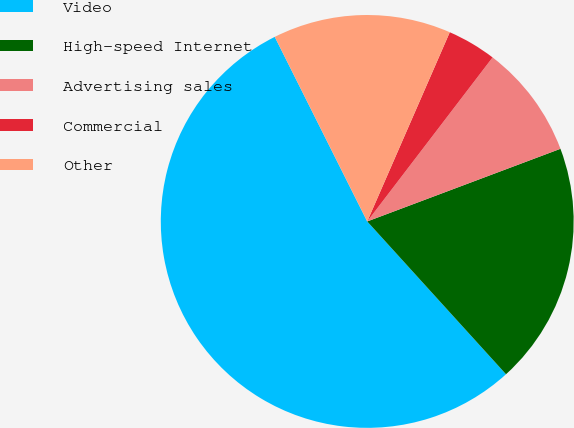Convert chart. <chart><loc_0><loc_0><loc_500><loc_500><pie_chart><fcel>Video<fcel>High-speed Internet<fcel>Advertising sales<fcel>Commercial<fcel>Other<nl><fcel>54.35%<fcel>18.99%<fcel>8.89%<fcel>3.84%<fcel>13.94%<nl></chart> 